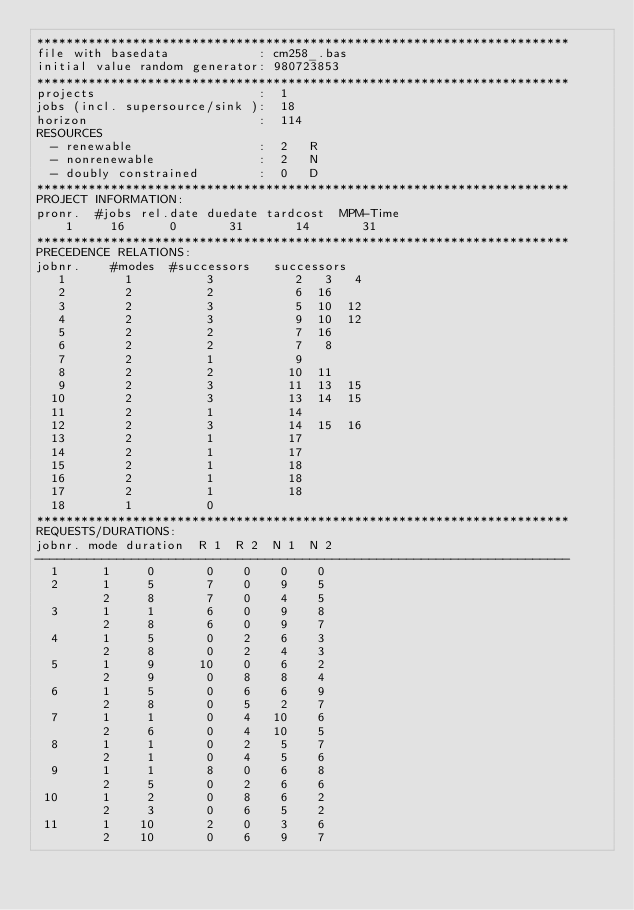Convert code to text. <code><loc_0><loc_0><loc_500><loc_500><_ObjectiveC_>************************************************************************
file with basedata            : cm258_.bas
initial value random generator: 980723853
************************************************************************
projects                      :  1
jobs (incl. supersource/sink ):  18
horizon                       :  114
RESOURCES
  - renewable                 :  2   R
  - nonrenewable              :  2   N
  - doubly constrained        :  0   D
************************************************************************
PROJECT INFORMATION:
pronr.  #jobs rel.date duedate tardcost  MPM-Time
    1     16      0       31       14       31
************************************************************************
PRECEDENCE RELATIONS:
jobnr.    #modes  #successors   successors
   1        1          3           2   3   4
   2        2          2           6  16
   3        2          3           5  10  12
   4        2          3           9  10  12
   5        2          2           7  16
   6        2          2           7   8
   7        2          1           9
   8        2          2          10  11
   9        2          3          11  13  15
  10        2          3          13  14  15
  11        2          1          14
  12        2          3          14  15  16
  13        2          1          17
  14        2          1          17
  15        2          1          18
  16        2          1          18
  17        2          1          18
  18        1          0        
************************************************************************
REQUESTS/DURATIONS:
jobnr. mode duration  R 1  R 2  N 1  N 2
------------------------------------------------------------------------
  1      1     0       0    0    0    0
  2      1     5       7    0    9    5
         2     8       7    0    4    5
  3      1     1       6    0    9    8
         2     8       6    0    9    7
  4      1     5       0    2    6    3
         2     8       0    2    4    3
  5      1     9      10    0    6    2
         2     9       0    8    8    4
  6      1     5       0    6    6    9
         2     8       0    5    2    7
  7      1     1       0    4   10    6
         2     6       0    4   10    5
  8      1     1       0    2    5    7
         2     1       0    4    5    6
  9      1     1       8    0    6    8
         2     5       0    2    6    6
 10      1     2       0    8    6    2
         2     3       0    6    5    2
 11      1    10       2    0    3    6
         2    10       0    6    9    7</code> 